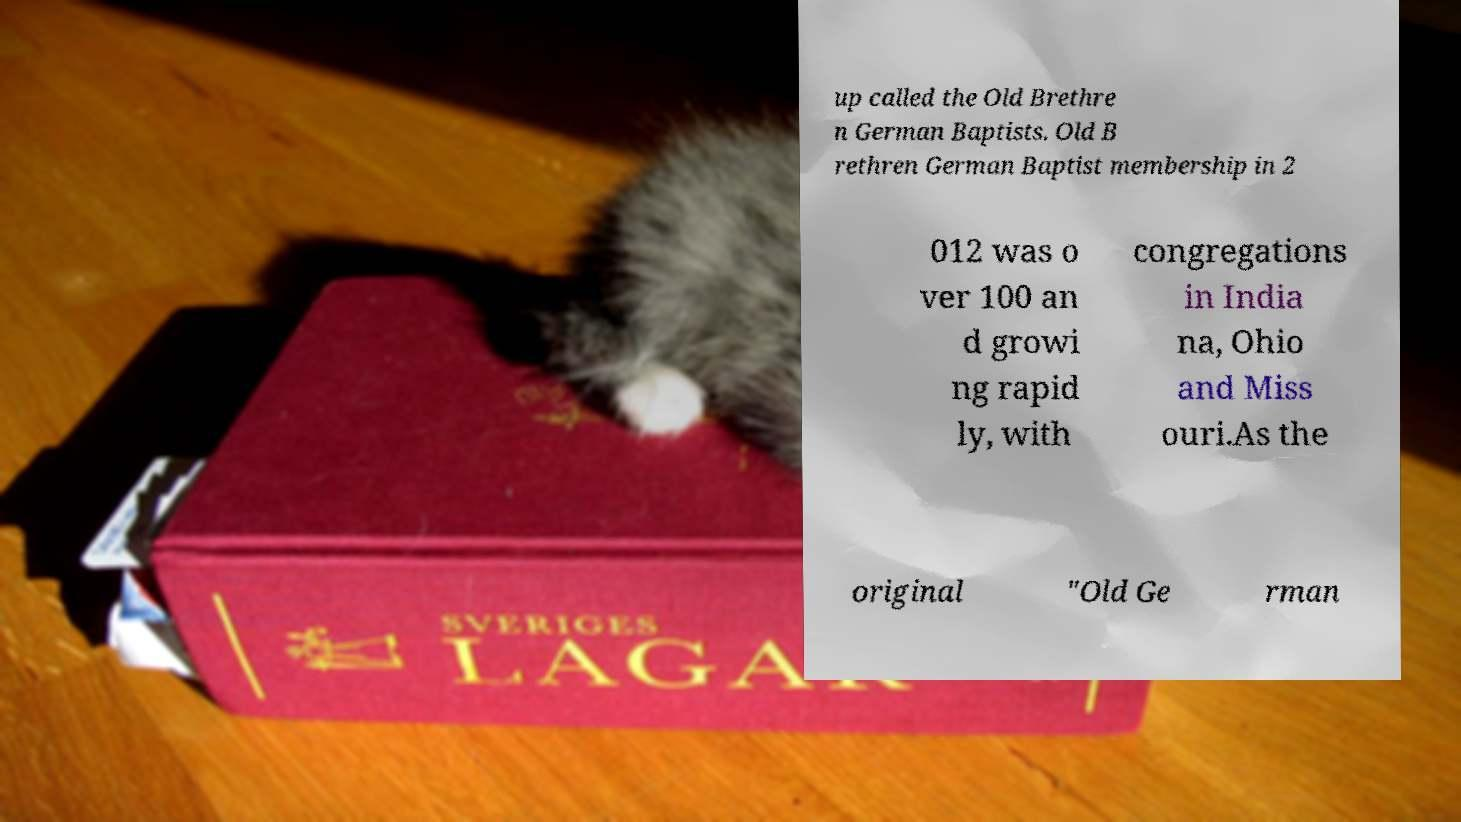Please identify and transcribe the text found in this image. up called the Old Brethre n German Baptists. Old B rethren German Baptist membership in 2 012 was o ver 100 an d growi ng rapid ly, with congregations in India na, Ohio and Miss ouri.As the original "Old Ge rman 